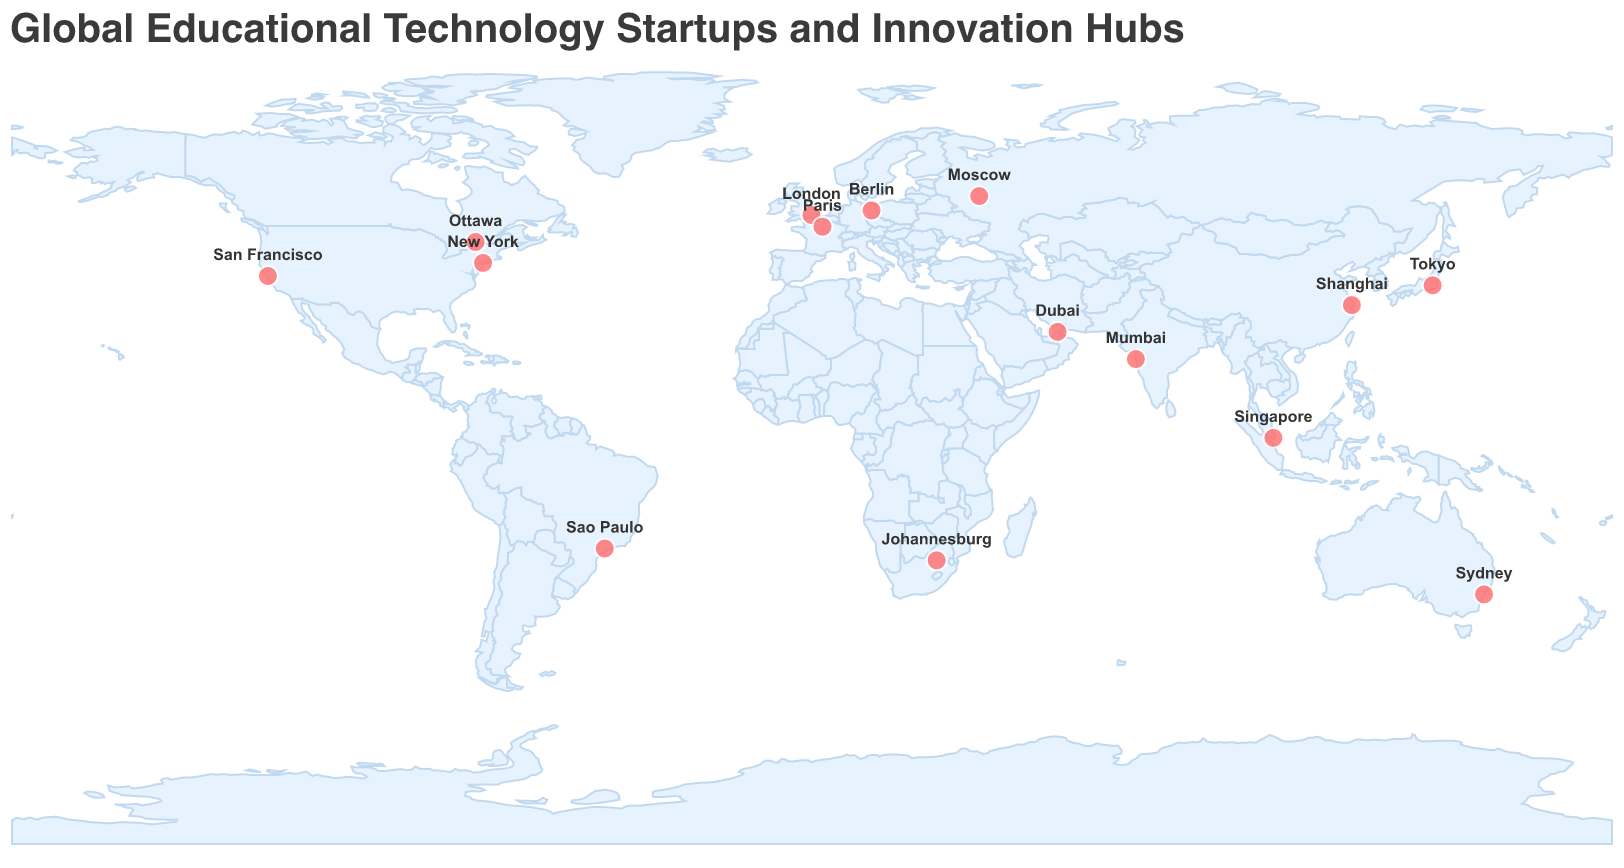Which country has the highest number of educational technology startups represented on the map? The figure has multiple startups marked around the world. The USA has two startups: ClassDojo in New York and Coursera in San Francisco, making it the country with the most startups represented.
Answer: USA How many educational technology startups are there in Europe? By visually locating the European countries on the map, the startups in Europe are: Century Tech in London (UK), Sofatutor in Berlin (Germany), and 360Learning in Paris (France). Thus, there are 3 startups in Europe.
Answer: 3 Which city is the innovation hub for AI-powered learning? Looking at the figure's tooltips, the innovation focus for AI-powered learning is found in the city of London, represented by Century Tech.
Answer: London Compare the innovation focuses in the USA. Are there more related to classroom management or online learning? The figure presents two startups in the USA: ClassDojo in New York with a focus on classroom management and Coursera in San Francisco focusing on online learning. Since there is one startup for each focus area, neither has more than the other.
Answer: Neither Which educational technology startup is located in South America? By checking the geographical locations on the map, the only startup located in South America is Descomplica, based in Sao Paulo, Brazil.
Answer: Descomplica Identify the startup with a focus on video lessons and its city of origin. The figure's tooltips show that Sofatutor is focused on video lessons and is located in Berlin, Germany.
Answer: Sofatutor in Berlin What is the common innovation focus among the startups in Asia, and which cities represent them? Scanning the Asian cities on the map, VIPKid in Shanghai (Online English Teaching), Skyeng in Moscow (Online English Learning), and Atama+ in Tokyo (Personalized Learning) appear. The common focus here is "Online English", represented in Shanghai and Moscow.
Answer: Online English; Shanghai and Moscow How many startups in the figure focus on AI-related educational technology? From the figure's tooltip information, Century Tech in London (AI-Powered Learning) and Geniebook in Singapore (AI Tutoring) are the two startups with AI-related focuses.
Answer: 2 What is the predominant innovation focus for educational technology startups in Asia? By reviewing the types of innovations in Asian cities, VIPKid in Shanghai and Skyeng in Moscow focus on online English, while Atama+ in Tokyo focuses on personalized learning. Thus, "Online English" is the predominant focus.
Answer: Online English 